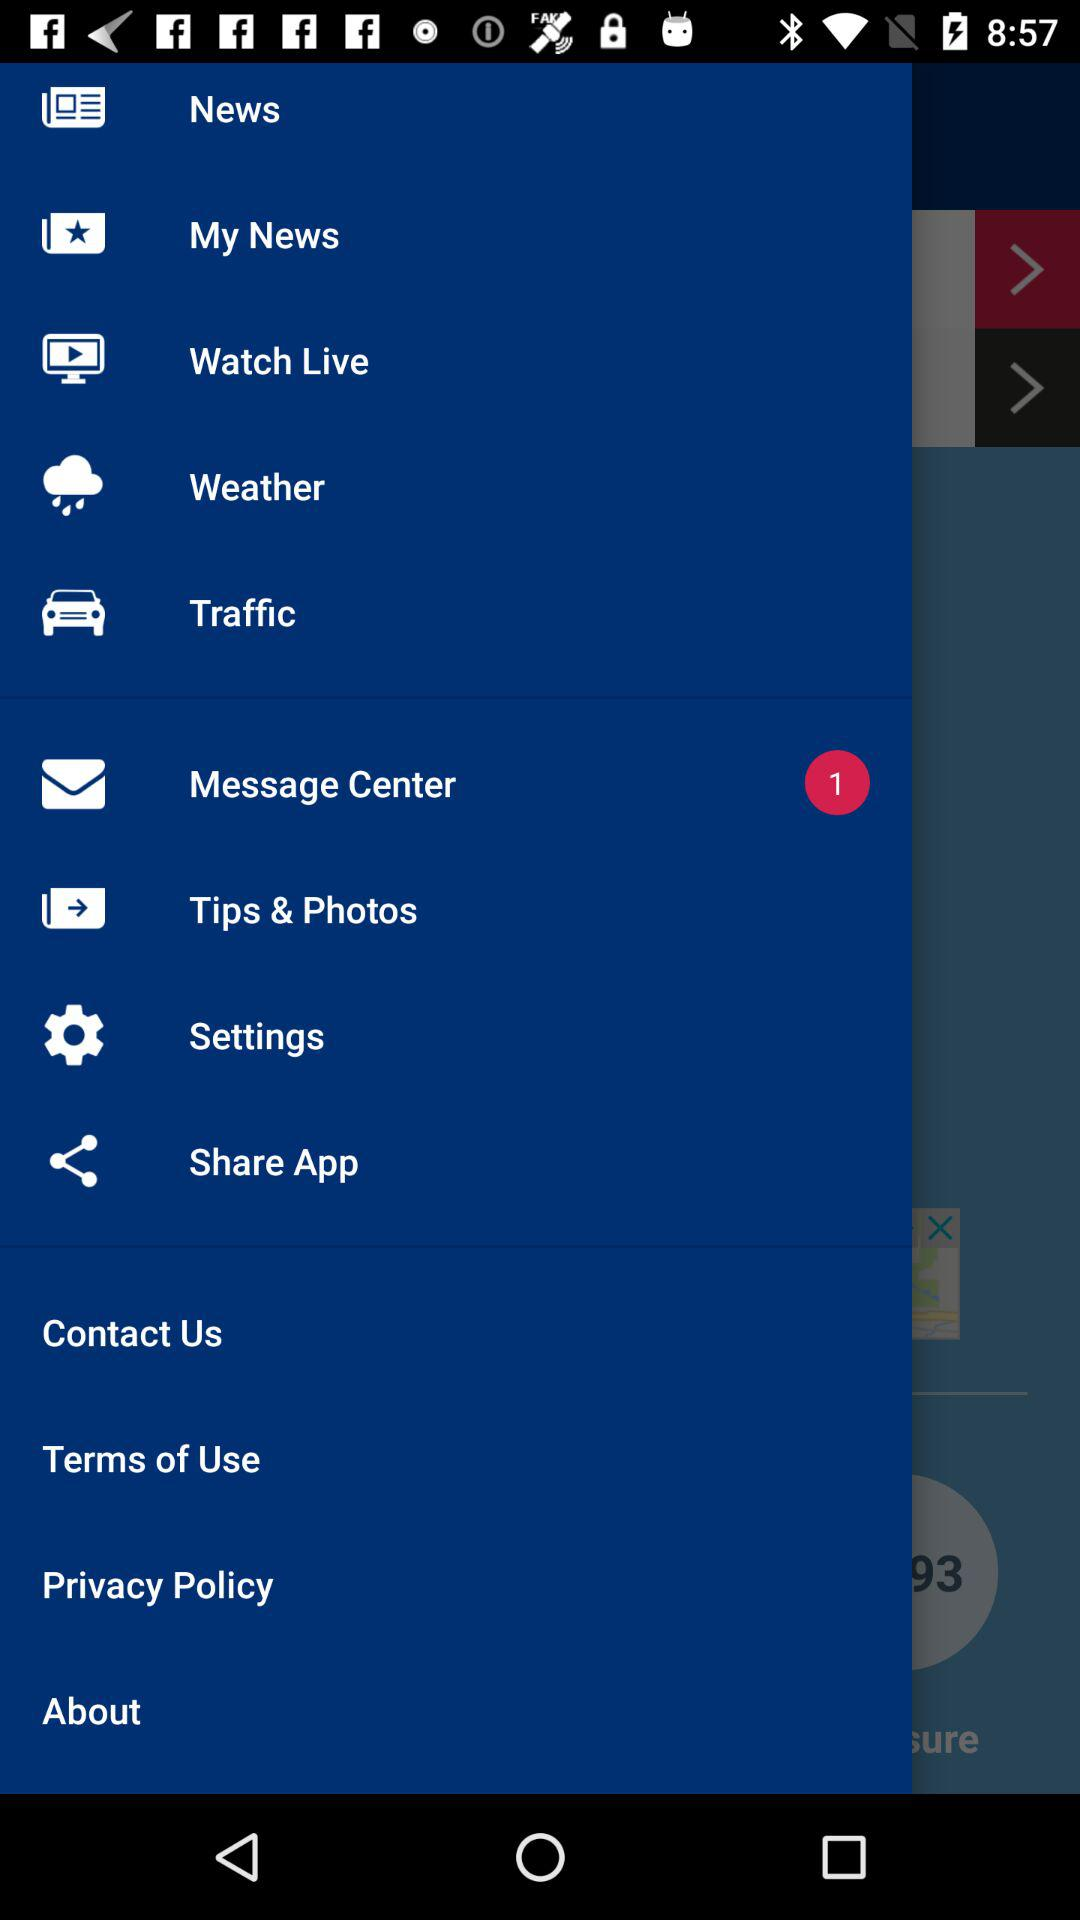Is there any unread message?
When the provided information is insufficient, respond with <no answer>. <no answer> 